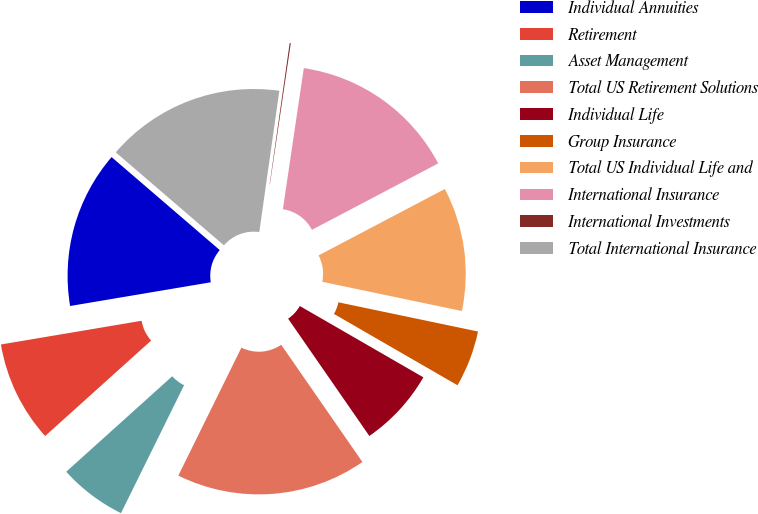Convert chart to OTSL. <chart><loc_0><loc_0><loc_500><loc_500><pie_chart><fcel>Individual Annuities<fcel>Retirement<fcel>Asset Management<fcel>Total US Retirement Solutions<fcel>Individual Life<fcel>Group Insurance<fcel>Total US Individual Life and<fcel>International Insurance<fcel>International Investments<fcel>Total International Insurance<nl><fcel>13.96%<fcel>9.01%<fcel>6.04%<fcel>16.93%<fcel>7.03%<fcel>5.05%<fcel>10.99%<fcel>14.95%<fcel>0.1%<fcel>15.94%<nl></chart> 